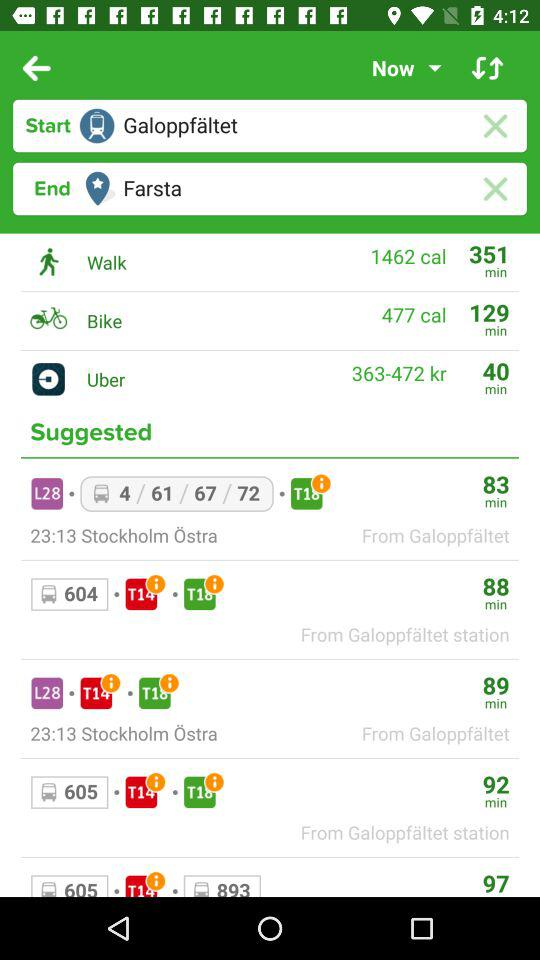How much time does it take on a bike? It takes 129 minutes on a bike. 